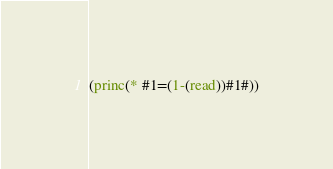<code> <loc_0><loc_0><loc_500><loc_500><_Lisp_>(princ(* #1=(1-(read))#1#))</code> 